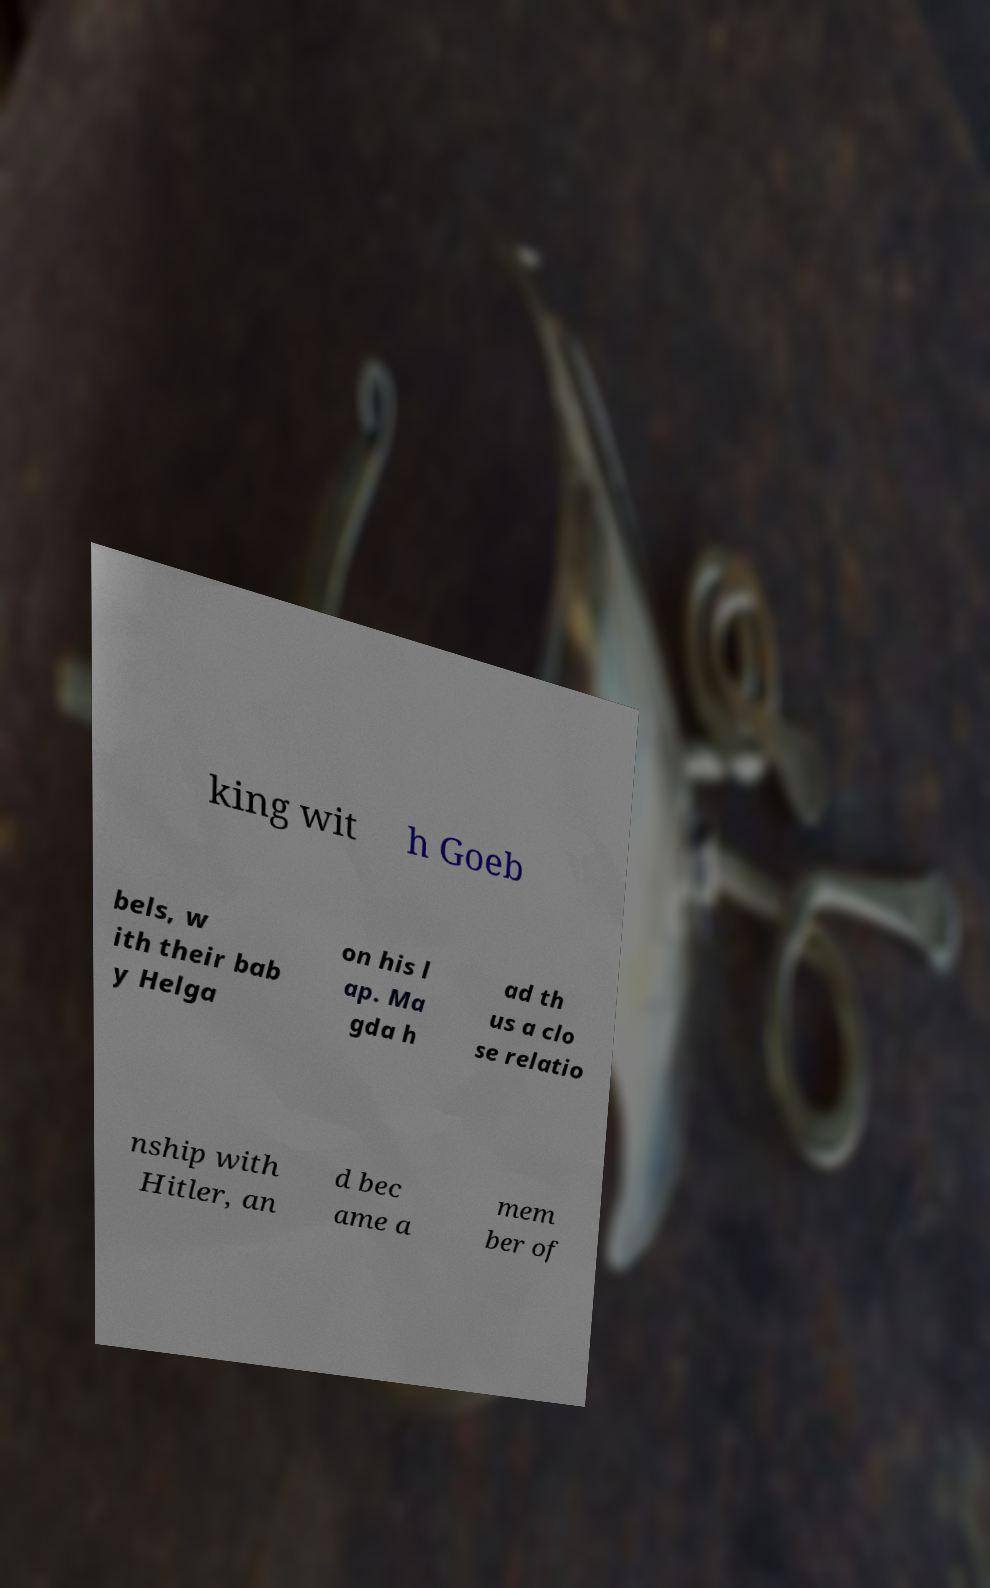Can you read and provide the text displayed in the image?This photo seems to have some interesting text. Can you extract and type it out for me? king wit h Goeb bels, w ith their bab y Helga on his l ap. Ma gda h ad th us a clo se relatio nship with Hitler, an d bec ame a mem ber of 